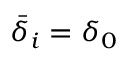<formula> <loc_0><loc_0><loc_500><loc_500>\bar { \delta } _ { i } = \delta _ { 0 }</formula> 